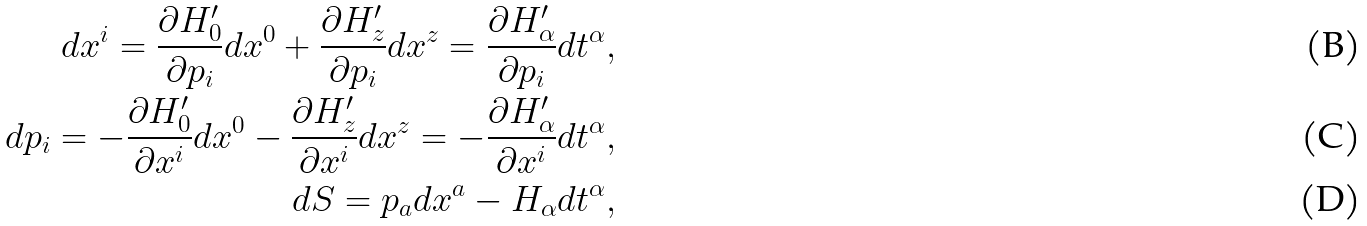<formula> <loc_0><loc_0><loc_500><loc_500>d x ^ { i } = \frac { \partial H ^ { \prime } _ { 0 } } { \partial p _ { i } } d x ^ { 0 } + \frac { \partial H ^ { \prime } _ { z } } { \partial p _ { i } } d x ^ { z } = \frac { \partial H ^ { \prime } _ { \alpha } } { \partial p _ { i } } d t ^ { \alpha } , \\ d p _ { i } = - \frac { \partial H ^ { \prime } _ { 0 } } { \partial x ^ { i } } d x ^ { 0 } - \frac { \partial H ^ { \prime } _ { z } } { \partial x ^ { i } } d x ^ { z } = - \frac { \partial H ^ { \prime } _ { \alpha } } { \partial x ^ { i } } d t ^ { \alpha } , \\ d S = p _ { a } d x ^ { a } - H _ { \alpha } d t ^ { \alpha } ,</formula> 